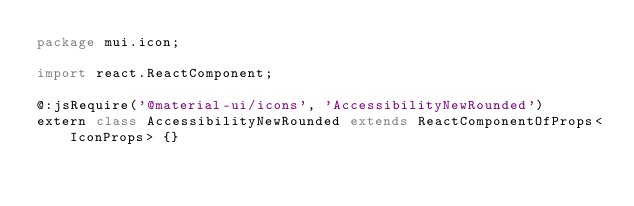<code> <loc_0><loc_0><loc_500><loc_500><_Haxe_>package mui.icon;

import react.ReactComponent;

@:jsRequire('@material-ui/icons', 'AccessibilityNewRounded')
extern class AccessibilityNewRounded extends ReactComponentOfProps<IconProps> {}
</code> 